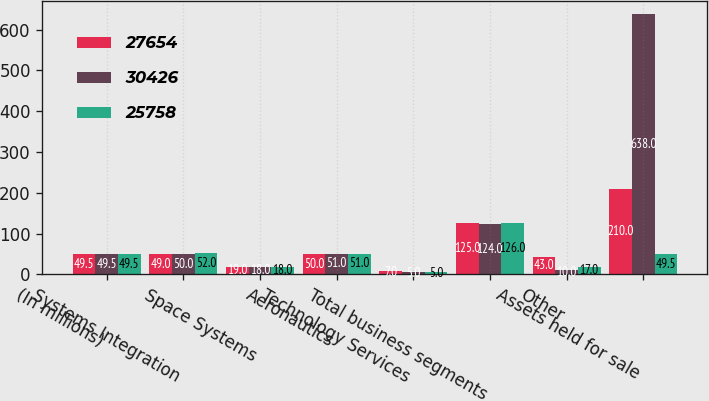Convert chart. <chart><loc_0><loc_0><loc_500><loc_500><stacked_bar_chart><ecel><fcel>(In millions)<fcel>Systems Integration<fcel>Space Systems<fcel>Aeronautics<fcel>Technology Services<fcel>Total business segments<fcel>Other<fcel>Assets held for sale<nl><fcel>27654<fcel>49.5<fcel>49<fcel>19<fcel>50<fcel>7<fcel>125<fcel>43<fcel>210<nl><fcel>30426<fcel>49.5<fcel>50<fcel>18<fcel>51<fcel>5<fcel>124<fcel>10<fcel>638<nl><fcel>25758<fcel>49.5<fcel>52<fcel>18<fcel>51<fcel>5<fcel>126<fcel>17<fcel>49.5<nl></chart> 